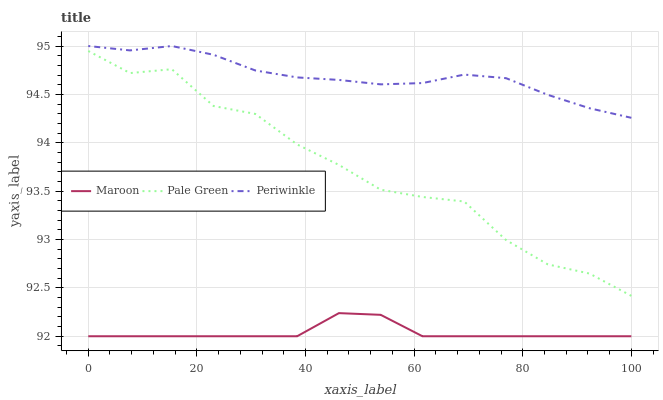Does Maroon have the minimum area under the curve?
Answer yes or no. Yes. Does Periwinkle have the maximum area under the curve?
Answer yes or no. Yes. Does Periwinkle have the minimum area under the curve?
Answer yes or no. No. Does Maroon have the maximum area under the curve?
Answer yes or no. No. Is Maroon the smoothest?
Answer yes or no. Yes. Is Pale Green the roughest?
Answer yes or no. Yes. Is Periwinkle the smoothest?
Answer yes or no. No. Is Periwinkle the roughest?
Answer yes or no. No. Does Periwinkle have the lowest value?
Answer yes or no. No. Does Periwinkle have the highest value?
Answer yes or no. Yes. Does Maroon have the highest value?
Answer yes or no. No. Is Maroon less than Pale Green?
Answer yes or no. Yes. Is Periwinkle greater than Pale Green?
Answer yes or no. Yes. Does Maroon intersect Pale Green?
Answer yes or no. No. 